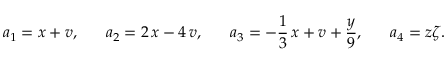Convert formula to latex. <formula><loc_0><loc_0><loc_500><loc_500>a _ { 1 } = x + v , \, a _ { 2 } = 2 \, x - 4 \, v , \, a _ { 3 } = - \frac { 1 } { 3 } \, x + v + \frac { y } { 9 } , \, a _ { 4 } = z \zeta .</formula> 